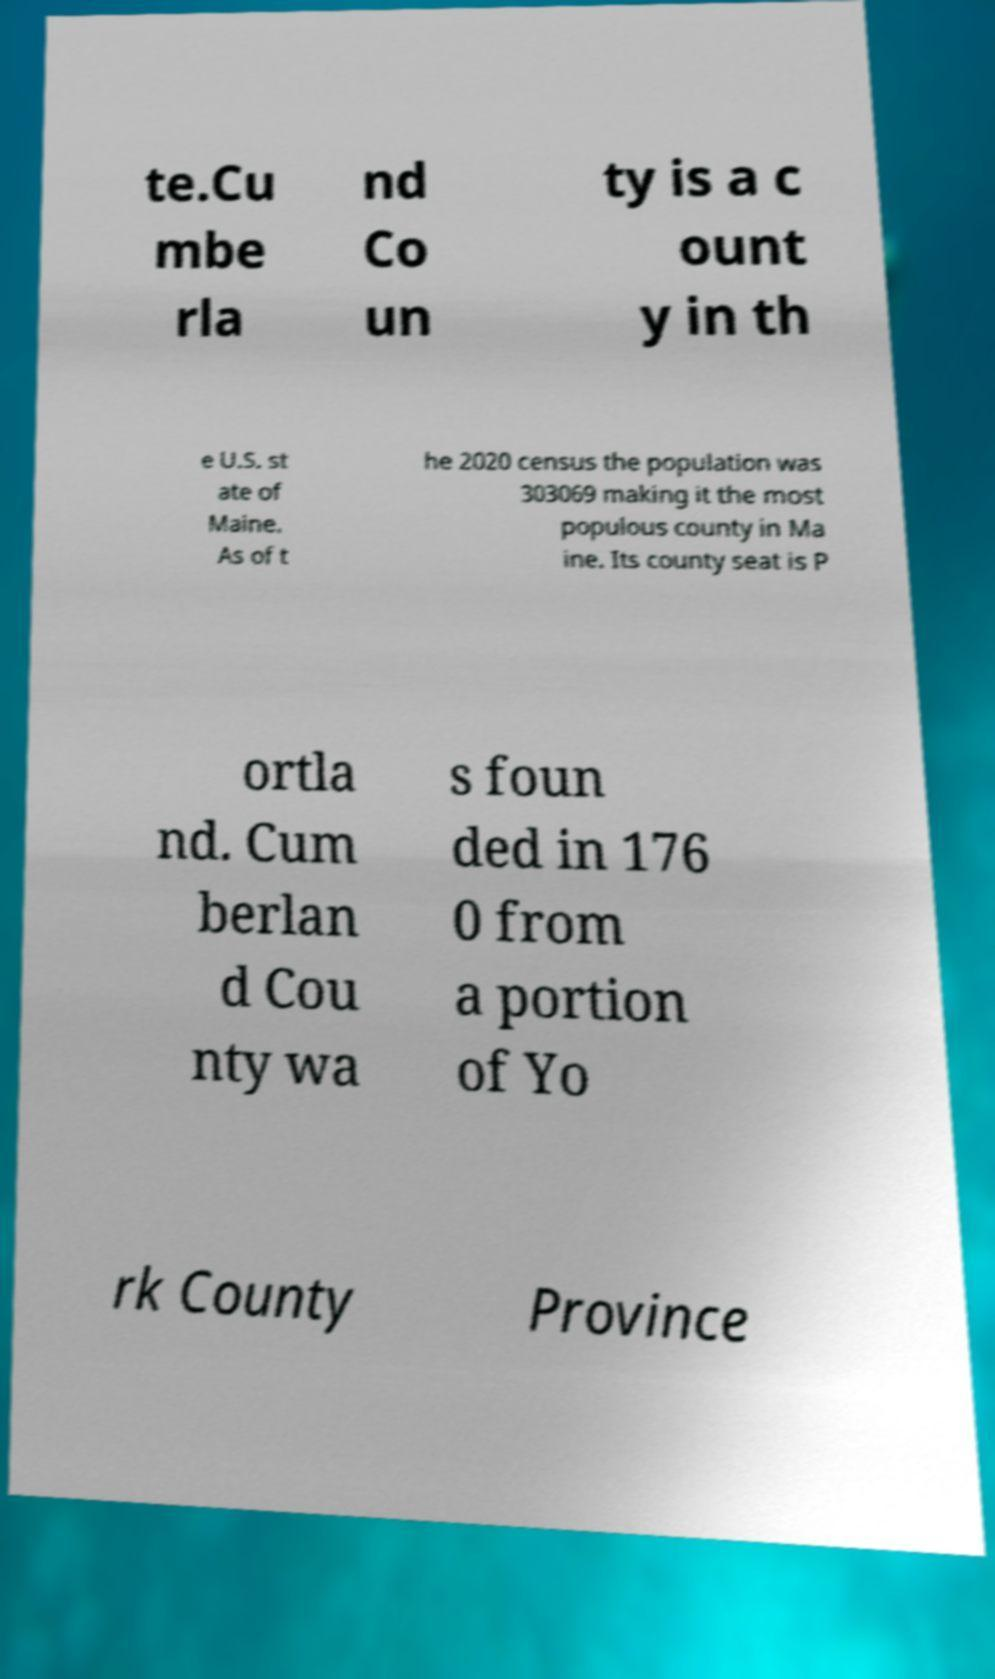For documentation purposes, I need the text within this image transcribed. Could you provide that? te.Cu mbe rla nd Co un ty is a c ount y in th e U.S. st ate of Maine. As of t he 2020 census the population was 303069 making it the most populous county in Ma ine. Its county seat is P ortla nd. Cum berlan d Cou nty wa s foun ded in 176 0 from a portion of Yo rk County Province 